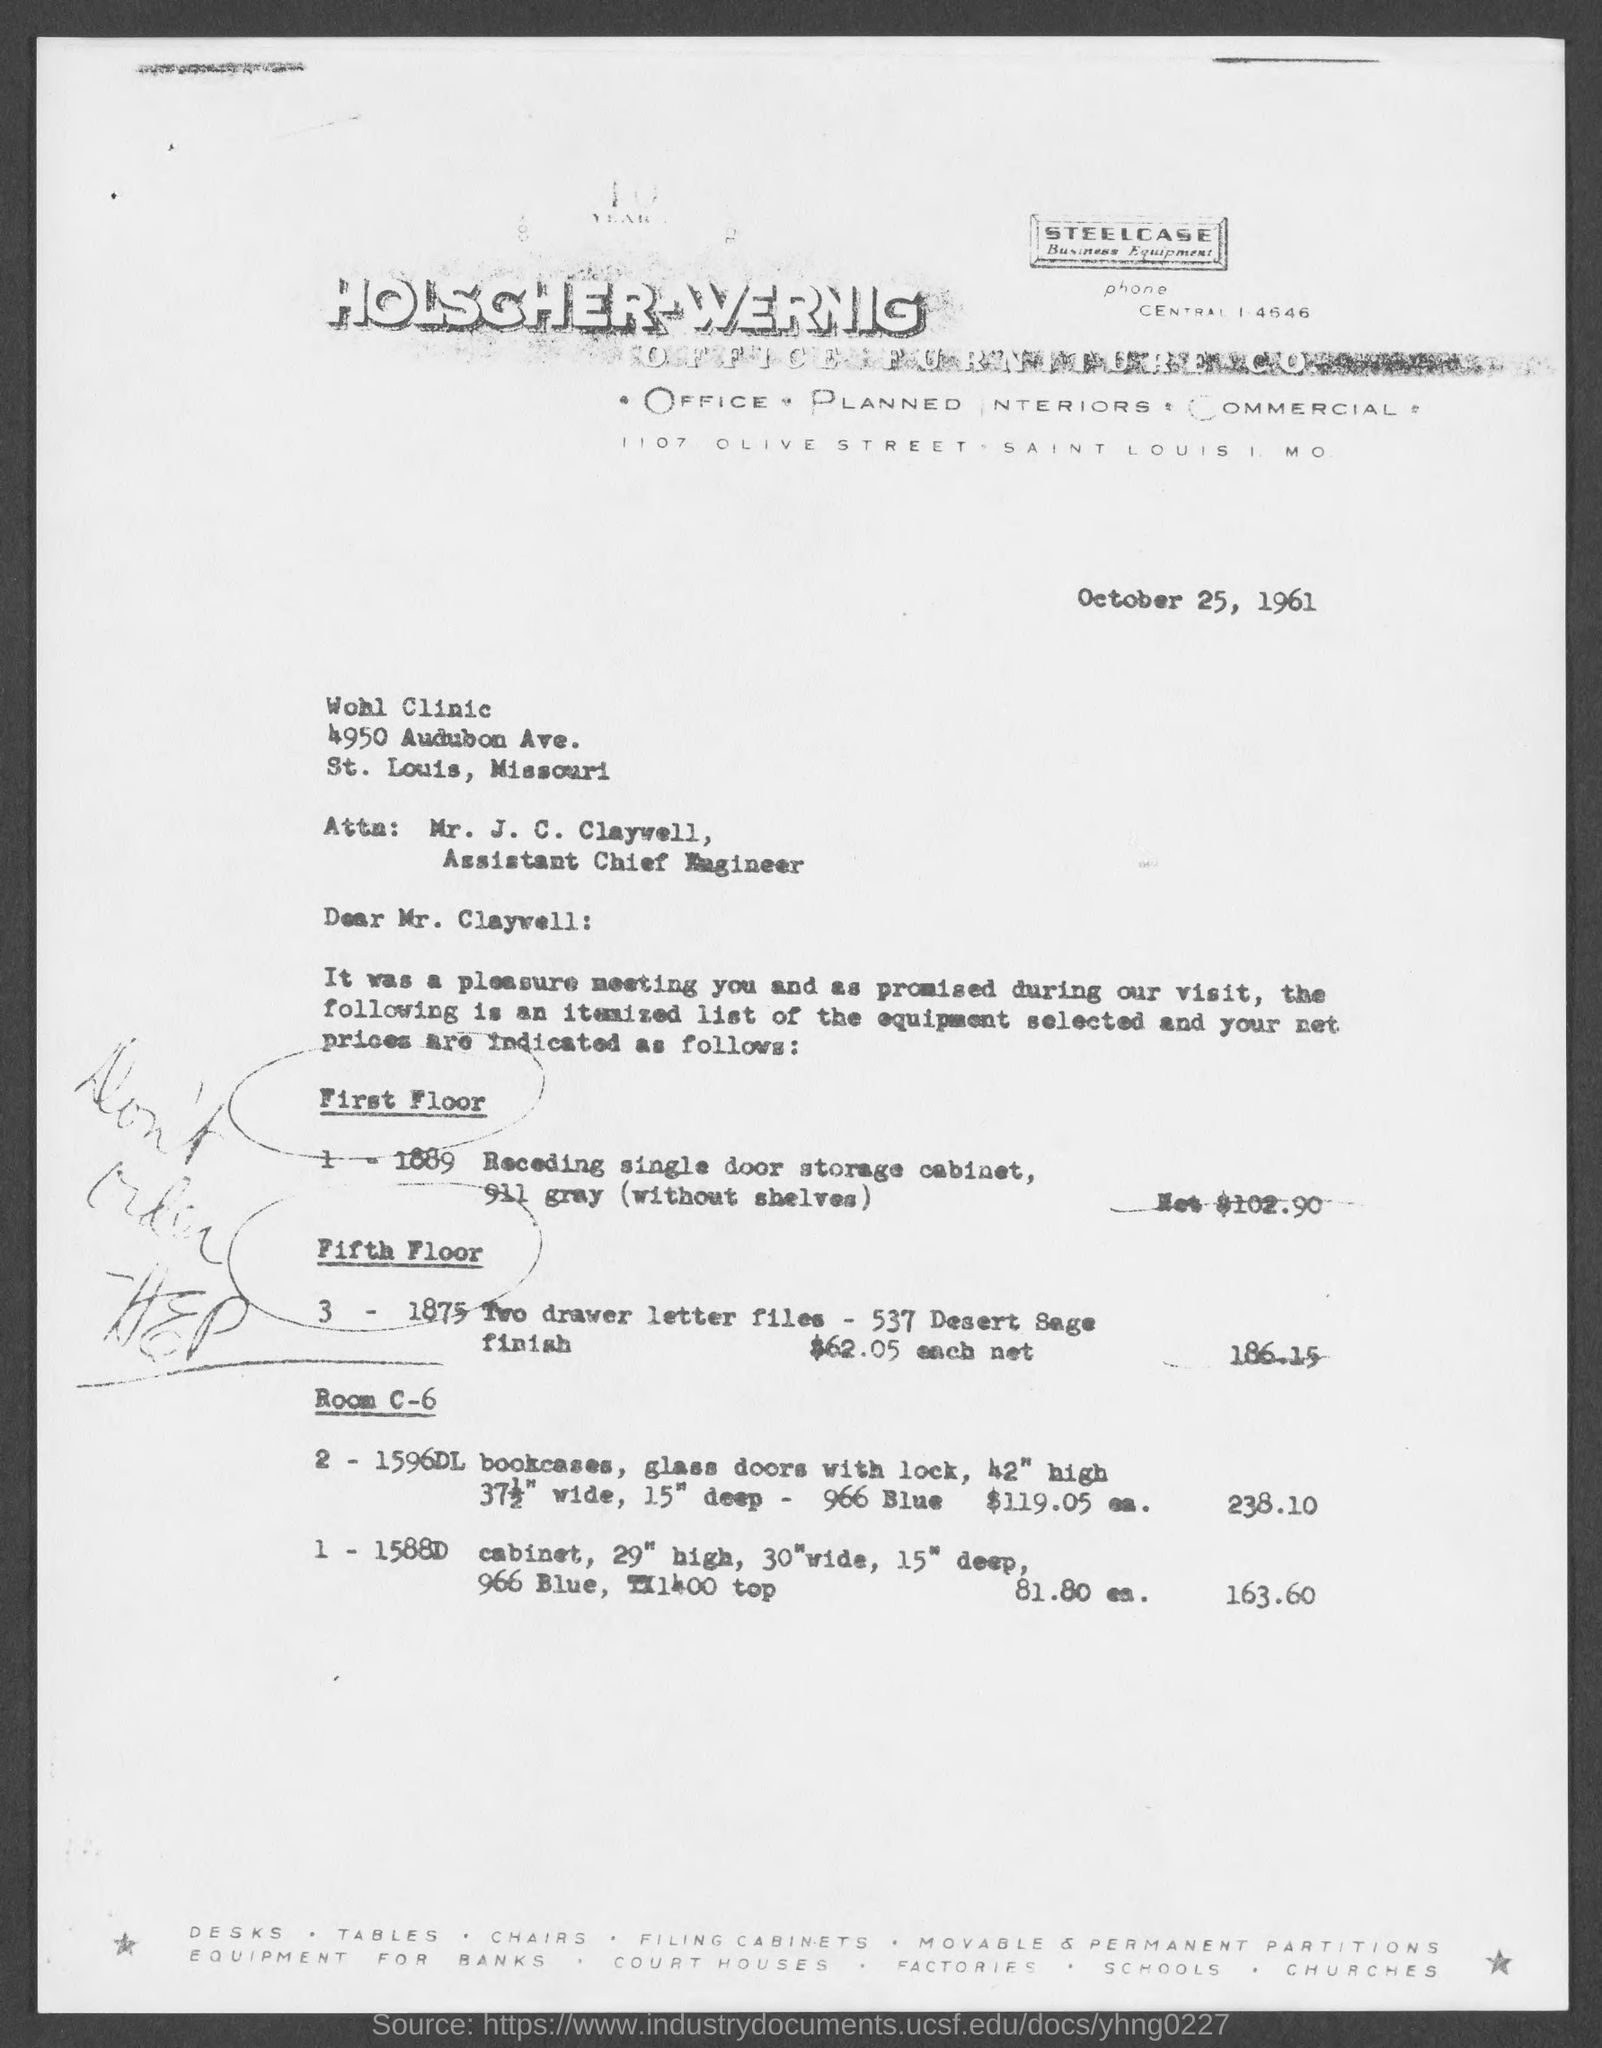Point out several critical features in this image. This letter is addressed to Mr. J. C. Claywell. The date on the document is October 25, 1961. 